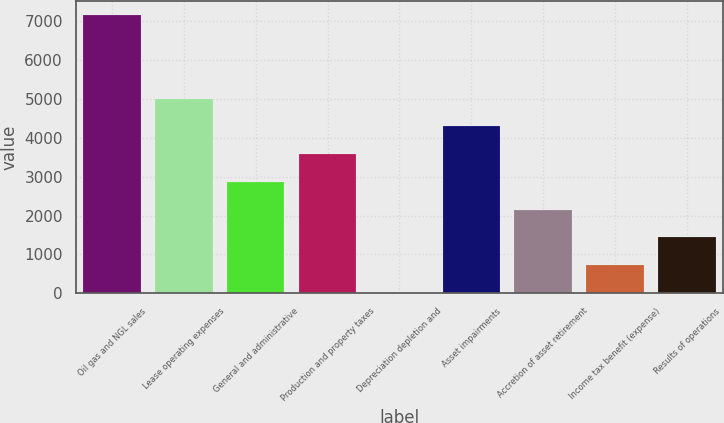Convert chart. <chart><loc_0><loc_0><loc_500><loc_500><bar_chart><fcel>Oil gas and NGL sales<fcel>Lease operating expenses<fcel>General and administrative<fcel>Production and property taxes<fcel>Depreciation depletion and<fcel>Asset impairments<fcel>Accretion of asset retirement<fcel>Income tax benefit (expense)<fcel>Results of operations<nl><fcel>7153<fcel>5010.15<fcel>2867.28<fcel>3581.57<fcel>10.12<fcel>4295.86<fcel>2152.99<fcel>724.41<fcel>1438.7<nl></chart> 